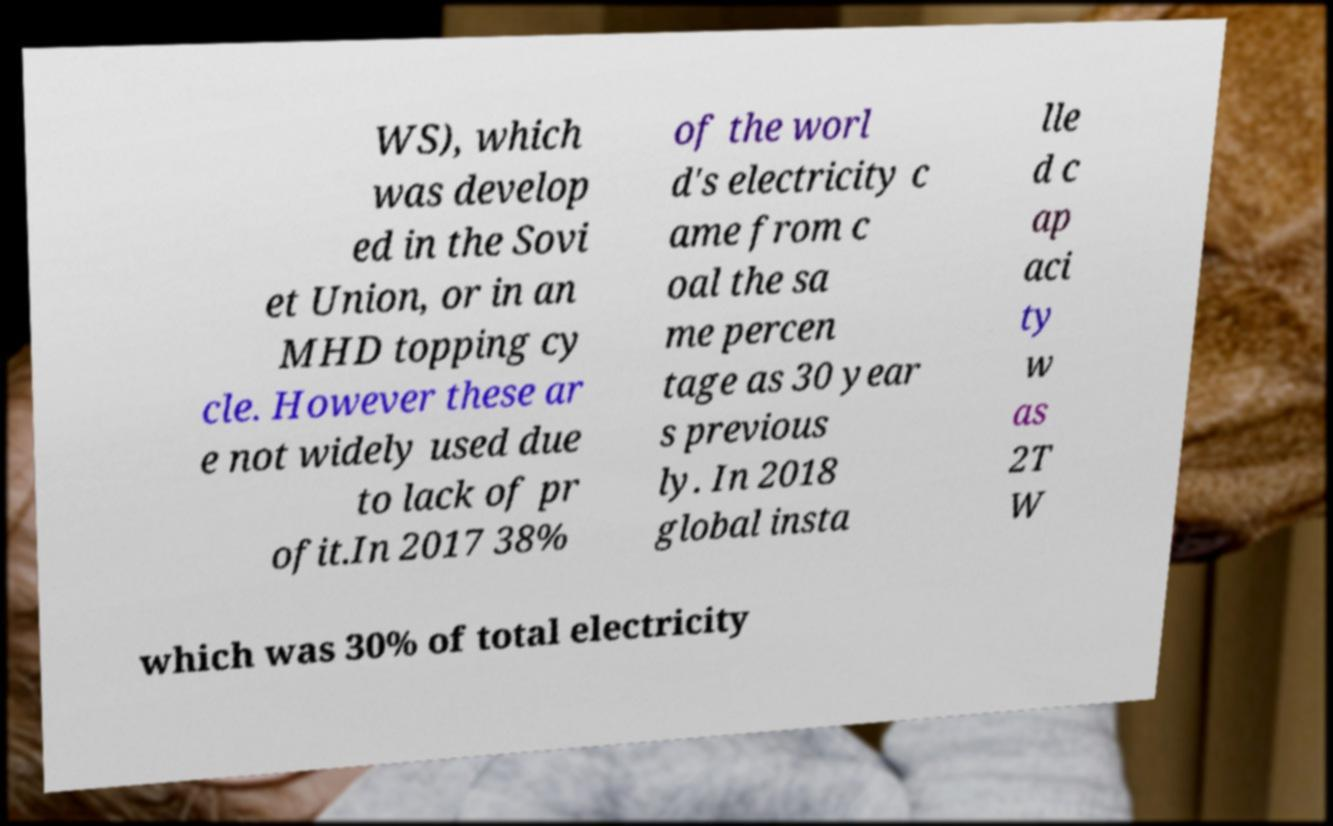What messages or text are displayed in this image? I need them in a readable, typed format. WS), which was develop ed in the Sovi et Union, or in an MHD topping cy cle. However these ar e not widely used due to lack of pr ofit.In 2017 38% of the worl d's electricity c ame from c oal the sa me percen tage as 30 year s previous ly. In 2018 global insta lle d c ap aci ty w as 2T W which was 30% of total electricity 